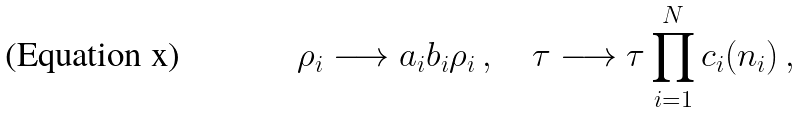Convert formula to latex. <formula><loc_0><loc_0><loc_500><loc_500>\rho _ { i } \longrightarrow a _ { i } b _ { i } \rho _ { i } \, , \quad \tau \longrightarrow \tau \prod _ { i = 1 } ^ { N } c _ { i } ( n _ { i } ) \, ,</formula> 